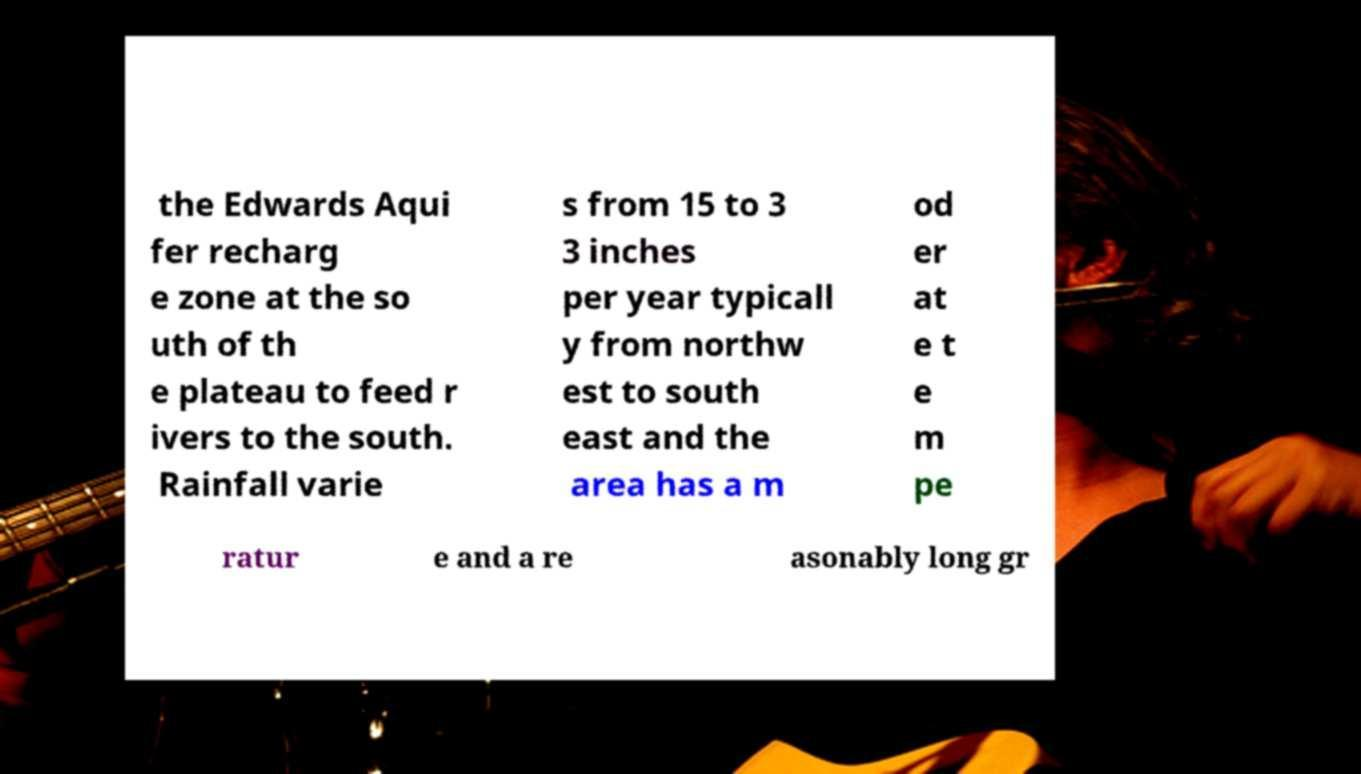Please read and relay the text visible in this image. What does it say? the Edwards Aqui fer recharg e zone at the so uth of th e plateau to feed r ivers to the south. Rainfall varie s from 15 to 3 3 inches per year typicall y from northw est to south east and the area has a m od er at e t e m pe ratur e and a re asonably long gr 